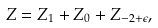Convert formula to latex. <formula><loc_0><loc_0><loc_500><loc_500>Z = Z _ { 1 } + Z _ { 0 } + Z _ { - 2 + \epsilon } ,</formula> 